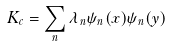Convert formula to latex. <formula><loc_0><loc_0><loc_500><loc_500>K _ { c } = \sum _ { n } \lambda _ { n } \psi _ { n } ( { x } ) \psi _ { n } ( { y } )</formula> 